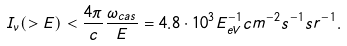<formula> <loc_0><loc_0><loc_500><loc_500>I _ { \nu } ( > E ) < \frac { 4 \pi } { c } \frac { \omega _ { c a s } } { E } = 4 . 8 \cdot 1 0 ^ { 3 } E _ { e V } ^ { - 1 } c m ^ { - 2 } s ^ { - 1 } s r ^ { - 1 } .</formula> 